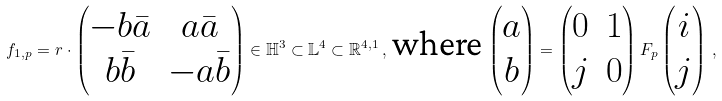Convert formula to latex. <formula><loc_0><loc_0><loc_500><loc_500>f _ { 1 , p } = r \cdot \begin{pmatrix} - b \bar { a } & a \bar { a } \\ b \bar { b } & - a \bar { b } \end{pmatrix} \in \mathbb { H } ^ { 3 } \subset \mathbb { L } ^ { 4 } \subset \mathbb { R } ^ { 4 , 1 } \, , \, \text {where} \, \begin{pmatrix} a \\ b \end{pmatrix} = \begin{pmatrix} 0 & 1 \\ j & 0 \end{pmatrix} F _ { p } \begin{pmatrix} i \\ j \end{pmatrix} \, ,</formula> 